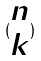Convert formula to latex. <formula><loc_0><loc_0><loc_500><loc_500>( \begin{matrix} n \\ k \end{matrix} )</formula> 